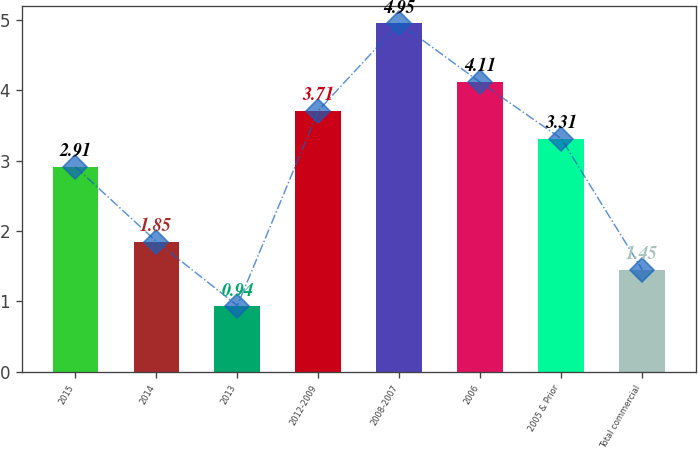Convert chart. <chart><loc_0><loc_0><loc_500><loc_500><bar_chart><fcel>2015<fcel>2014<fcel>2013<fcel>2012-2009<fcel>2008-2007<fcel>2006<fcel>2005 & Prior<fcel>Total commercial<nl><fcel>2.91<fcel>1.85<fcel>0.94<fcel>3.71<fcel>4.95<fcel>4.11<fcel>3.31<fcel>1.45<nl></chart> 